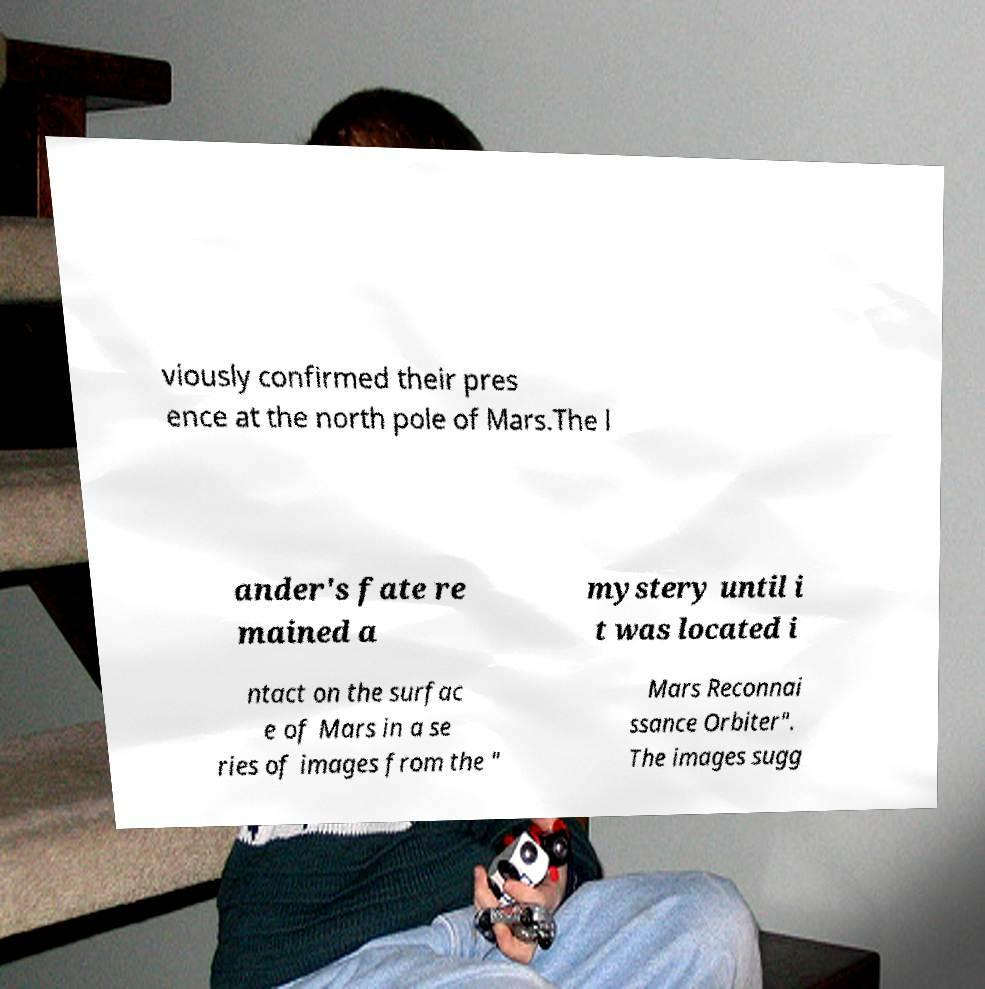Could you extract and type out the text from this image? viously confirmed their pres ence at the north pole of Mars.The l ander's fate re mained a mystery until i t was located i ntact on the surfac e of Mars in a se ries of images from the " Mars Reconnai ssance Orbiter". The images sugg 